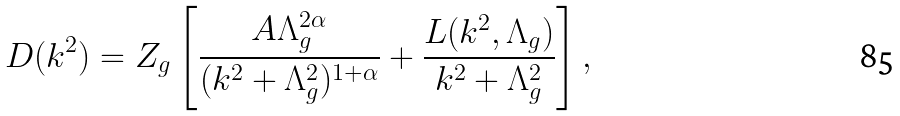Convert formula to latex. <formula><loc_0><loc_0><loc_500><loc_500>D ( k ^ { 2 } ) = Z _ { g } \left [ \frac { A \Lambda _ { g } ^ { 2 \alpha } } { ( k ^ { 2 } + \Lambda _ { g } ^ { 2 } ) ^ { 1 + \alpha } } + \frac { L ( k ^ { 2 } , \Lambda _ { g } ) } { k ^ { 2 } + \Lambda _ { g } ^ { 2 } } \right ] ,</formula> 